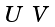<formula> <loc_0><loc_0><loc_500><loc_500>\begin{smallmatrix} U & V \end{smallmatrix}</formula> 